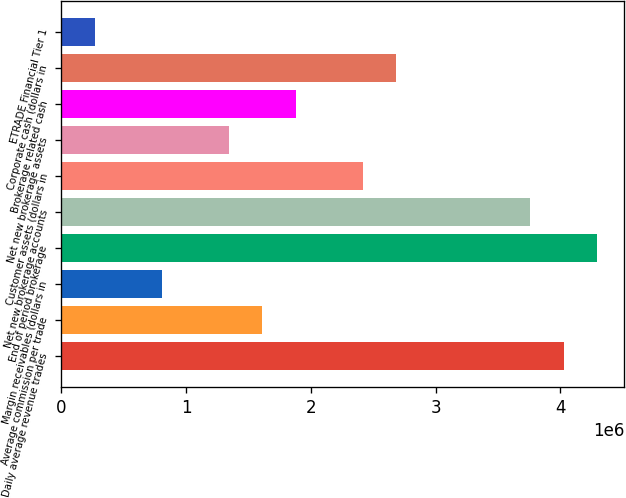Convert chart to OTSL. <chart><loc_0><loc_0><loc_500><loc_500><bar_chart><fcel>Daily average revenue trades<fcel>Average commission per trade<fcel>Margin receivables (dollars in<fcel>End of period brokerage<fcel>Net new brokerage accounts<fcel>Customer assets (dollars in<fcel>Net new brokerage assets<fcel>Brokerage related cash<fcel>Corporate cash (dollars in<fcel>ETRADE Financial Tier 1<nl><fcel>4.02647e+06<fcel>1.61059e+06<fcel>805295<fcel>4.2949e+06<fcel>3.75803e+06<fcel>2.41588e+06<fcel>1.34216e+06<fcel>1.87902e+06<fcel>2.68431e+06<fcel>268434<nl></chart> 